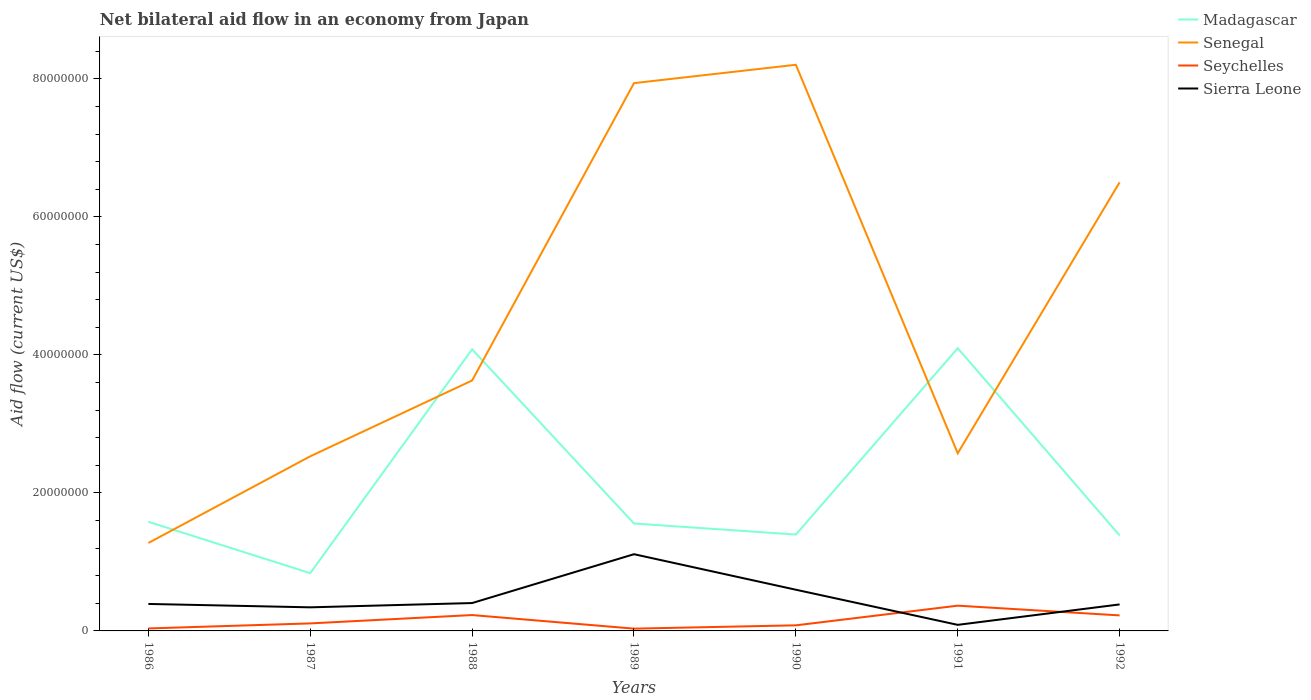How many different coloured lines are there?
Keep it short and to the point. 4. Is the number of lines equal to the number of legend labels?
Give a very brief answer. Yes. Across all years, what is the maximum net bilateral aid flow in Madagascar?
Your answer should be very brief. 8.37e+06. In which year was the net bilateral aid flow in Seychelles maximum?
Your response must be concise. 1989. What is the total net bilateral aid flow in Madagascar in the graph?
Your answer should be very brief. 2.52e+07. What is the difference between the highest and the second highest net bilateral aid flow in Sierra Leone?
Your answer should be compact. 1.02e+07. Is the net bilateral aid flow in Seychelles strictly greater than the net bilateral aid flow in Madagascar over the years?
Your answer should be very brief. Yes. What is the difference between two consecutive major ticks on the Y-axis?
Offer a terse response. 2.00e+07. Are the values on the major ticks of Y-axis written in scientific E-notation?
Ensure brevity in your answer.  No. Does the graph contain any zero values?
Make the answer very short. No. Does the graph contain grids?
Give a very brief answer. No. Where does the legend appear in the graph?
Provide a short and direct response. Top right. What is the title of the graph?
Offer a very short reply. Net bilateral aid flow in an economy from Japan. Does "Nicaragua" appear as one of the legend labels in the graph?
Offer a terse response. No. What is the label or title of the X-axis?
Make the answer very short. Years. What is the Aid flow (current US$) of Madagascar in 1986?
Provide a succinct answer. 1.58e+07. What is the Aid flow (current US$) in Senegal in 1986?
Your answer should be compact. 1.28e+07. What is the Aid flow (current US$) in Sierra Leone in 1986?
Keep it short and to the point. 3.91e+06. What is the Aid flow (current US$) of Madagascar in 1987?
Keep it short and to the point. 8.37e+06. What is the Aid flow (current US$) in Senegal in 1987?
Keep it short and to the point. 2.53e+07. What is the Aid flow (current US$) in Seychelles in 1987?
Give a very brief answer. 1.09e+06. What is the Aid flow (current US$) in Sierra Leone in 1987?
Offer a very short reply. 3.42e+06. What is the Aid flow (current US$) of Madagascar in 1988?
Ensure brevity in your answer.  4.08e+07. What is the Aid flow (current US$) in Senegal in 1988?
Your answer should be compact. 3.63e+07. What is the Aid flow (current US$) of Seychelles in 1988?
Provide a succinct answer. 2.30e+06. What is the Aid flow (current US$) of Sierra Leone in 1988?
Your response must be concise. 4.04e+06. What is the Aid flow (current US$) in Madagascar in 1989?
Keep it short and to the point. 1.56e+07. What is the Aid flow (current US$) in Senegal in 1989?
Provide a succinct answer. 7.94e+07. What is the Aid flow (current US$) of Sierra Leone in 1989?
Keep it short and to the point. 1.11e+07. What is the Aid flow (current US$) in Madagascar in 1990?
Offer a very short reply. 1.40e+07. What is the Aid flow (current US$) in Senegal in 1990?
Your answer should be very brief. 8.21e+07. What is the Aid flow (current US$) of Seychelles in 1990?
Your response must be concise. 8.10e+05. What is the Aid flow (current US$) of Sierra Leone in 1990?
Your answer should be very brief. 5.97e+06. What is the Aid flow (current US$) in Madagascar in 1991?
Keep it short and to the point. 4.10e+07. What is the Aid flow (current US$) in Senegal in 1991?
Make the answer very short. 2.58e+07. What is the Aid flow (current US$) of Seychelles in 1991?
Make the answer very short. 3.66e+06. What is the Aid flow (current US$) in Sierra Leone in 1991?
Your response must be concise. 8.80e+05. What is the Aid flow (current US$) in Madagascar in 1992?
Offer a very short reply. 1.38e+07. What is the Aid flow (current US$) in Senegal in 1992?
Provide a short and direct response. 6.50e+07. What is the Aid flow (current US$) in Seychelles in 1992?
Provide a succinct answer. 2.25e+06. What is the Aid flow (current US$) of Sierra Leone in 1992?
Your response must be concise. 3.84e+06. Across all years, what is the maximum Aid flow (current US$) in Madagascar?
Ensure brevity in your answer.  4.10e+07. Across all years, what is the maximum Aid flow (current US$) of Senegal?
Your response must be concise. 8.21e+07. Across all years, what is the maximum Aid flow (current US$) of Seychelles?
Offer a terse response. 3.66e+06. Across all years, what is the maximum Aid flow (current US$) of Sierra Leone?
Your answer should be compact. 1.11e+07. Across all years, what is the minimum Aid flow (current US$) in Madagascar?
Offer a very short reply. 8.37e+06. Across all years, what is the minimum Aid flow (current US$) of Senegal?
Make the answer very short. 1.28e+07. Across all years, what is the minimum Aid flow (current US$) of Seychelles?
Your answer should be compact. 3.30e+05. Across all years, what is the minimum Aid flow (current US$) of Sierra Leone?
Give a very brief answer. 8.80e+05. What is the total Aid flow (current US$) of Madagascar in the graph?
Offer a terse response. 1.49e+08. What is the total Aid flow (current US$) of Senegal in the graph?
Keep it short and to the point. 3.27e+08. What is the total Aid flow (current US$) in Seychelles in the graph?
Offer a very short reply. 1.08e+07. What is the total Aid flow (current US$) in Sierra Leone in the graph?
Give a very brief answer. 3.32e+07. What is the difference between the Aid flow (current US$) in Madagascar in 1986 and that in 1987?
Your answer should be very brief. 7.45e+06. What is the difference between the Aid flow (current US$) in Senegal in 1986 and that in 1987?
Your answer should be compact. -1.26e+07. What is the difference between the Aid flow (current US$) in Seychelles in 1986 and that in 1987?
Give a very brief answer. -7.30e+05. What is the difference between the Aid flow (current US$) of Madagascar in 1986 and that in 1988?
Make the answer very short. -2.50e+07. What is the difference between the Aid flow (current US$) of Senegal in 1986 and that in 1988?
Offer a very short reply. -2.36e+07. What is the difference between the Aid flow (current US$) in Seychelles in 1986 and that in 1988?
Offer a terse response. -1.94e+06. What is the difference between the Aid flow (current US$) of Sierra Leone in 1986 and that in 1988?
Give a very brief answer. -1.30e+05. What is the difference between the Aid flow (current US$) in Senegal in 1986 and that in 1989?
Offer a very short reply. -6.66e+07. What is the difference between the Aid flow (current US$) of Sierra Leone in 1986 and that in 1989?
Give a very brief answer. -7.21e+06. What is the difference between the Aid flow (current US$) of Madagascar in 1986 and that in 1990?
Keep it short and to the point. 1.85e+06. What is the difference between the Aid flow (current US$) of Senegal in 1986 and that in 1990?
Offer a terse response. -6.93e+07. What is the difference between the Aid flow (current US$) of Seychelles in 1986 and that in 1990?
Ensure brevity in your answer.  -4.50e+05. What is the difference between the Aid flow (current US$) in Sierra Leone in 1986 and that in 1990?
Make the answer very short. -2.06e+06. What is the difference between the Aid flow (current US$) of Madagascar in 1986 and that in 1991?
Give a very brief answer. -2.52e+07. What is the difference between the Aid flow (current US$) in Senegal in 1986 and that in 1991?
Your response must be concise. -1.30e+07. What is the difference between the Aid flow (current US$) of Seychelles in 1986 and that in 1991?
Provide a succinct answer. -3.30e+06. What is the difference between the Aid flow (current US$) of Sierra Leone in 1986 and that in 1991?
Your response must be concise. 3.03e+06. What is the difference between the Aid flow (current US$) in Madagascar in 1986 and that in 1992?
Provide a succinct answer. 1.98e+06. What is the difference between the Aid flow (current US$) of Senegal in 1986 and that in 1992?
Offer a very short reply. -5.23e+07. What is the difference between the Aid flow (current US$) of Seychelles in 1986 and that in 1992?
Your answer should be very brief. -1.89e+06. What is the difference between the Aid flow (current US$) in Sierra Leone in 1986 and that in 1992?
Offer a very short reply. 7.00e+04. What is the difference between the Aid flow (current US$) in Madagascar in 1987 and that in 1988?
Make the answer very short. -3.24e+07. What is the difference between the Aid flow (current US$) in Senegal in 1987 and that in 1988?
Your answer should be very brief. -1.10e+07. What is the difference between the Aid flow (current US$) of Seychelles in 1987 and that in 1988?
Provide a short and direct response. -1.21e+06. What is the difference between the Aid flow (current US$) in Sierra Leone in 1987 and that in 1988?
Give a very brief answer. -6.20e+05. What is the difference between the Aid flow (current US$) in Madagascar in 1987 and that in 1989?
Ensure brevity in your answer.  -7.20e+06. What is the difference between the Aid flow (current US$) of Senegal in 1987 and that in 1989?
Give a very brief answer. -5.41e+07. What is the difference between the Aid flow (current US$) in Seychelles in 1987 and that in 1989?
Your answer should be compact. 7.60e+05. What is the difference between the Aid flow (current US$) of Sierra Leone in 1987 and that in 1989?
Give a very brief answer. -7.70e+06. What is the difference between the Aid flow (current US$) in Madagascar in 1987 and that in 1990?
Your answer should be very brief. -5.60e+06. What is the difference between the Aid flow (current US$) in Senegal in 1987 and that in 1990?
Your answer should be very brief. -5.68e+07. What is the difference between the Aid flow (current US$) of Sierra Leone in 1987 and that in 1990?
Your answer should be compact. -2.55e+06. What is the difference between the Aid flow (current US$) in Madagascar in 1987 and that in 1991?
Offer a terse response. -3.26e+07. What is the difference between the Aid flow (current US$) in Senegal in 1987 and that in 1991?
Provide a short and direct response. -4.40e+05. What is the difference between the Aid flow (current US$) in Seychelles in 1987 and that in 1991?
Your response must be concise. -2.57e+06. What is the difference between the Aid flow (current US$) of Sierra Leone in 1987 and that in 1991?
Offer a terse response. 2.54e+06. What is the difference between the Aid flow (current US$) in Madagascar in 1987 and that in 1992?
Provide a succinct answer. -5.47e+06. What is the difference between the Aid flow (current US$) in Senegal in 1987 and that in 1992?
Keep it short and to the point. -3.97e+07. What is the difference between the Aid flow (current US$) in Seychelles in 1987 and that in 1992?
Ensure brevity in your answer.  -1.16e+06. What is the difference between the Aid flow (current US$) of Sierra Leone in 1987 and that in 1992?
Your answer should be compact. -4.20e+05. What is the difference between the Aid flow (current US$) in Madagascar in 1988 and that in 1989?
Provide a succinct answer. 2.52e+07. What is the difference between the Aid flow (current US$) in Senegal in 1988 and that in 1989?
Ensure brevity in your answer.  -4.31e+07. What is the difference between the Aid flow (current US$) of Seychelles in 1988 and that in 1989?
Provide a short and direct response. 1.97e+06. What is the difference between the Aid flow (current US$) of Sierra Leone in 1988 and that in 1989?
Provide a succinct answer. -7.08e+06. What is the difference between the Aid flow (current US$) in Madagascar in 1988 and that in 1990?
Your answer should be compact. 2.68e+07. What is the difference between the Aid flow (current US$) of Senegal in 1988 and that in 1990?
Offer a terse response. -4.58e+07. What is the difference between the Aid flow (current US$) in Seychelles in 1988 and that in 1990?
Your answer should be compact. 1.49e+06. What is the difference between the Aid flow (current US$) in Sierra Leone in 1988 and that in 1990?
Keep it short and to the point. -1.93e+06. What is the difference between the Aid flow (current US$) in Madagascar in 1988 and that in 1991?
Provide a succinct answer. -1.60e+05. What is the difference between the Aid flow (current US$) of Senegal in 1988 and that in 1991?
Your response must be concise. 1.06e+07. What is the difference between the Aid flow (current US$) in Seychelles in 1988 and that in 1991?
Make the answer very short. -1.36e+06. What is the difference between the Aid flow (current US$) of Sierra Leone in 1988 and that in 1991?
Provide a short and direct response. 3.16e+06. What is the difference between the Aid flow (current US$) of Madagascar in 1988 and that in 1992?
Ensure brevity in your answer.  2.70e+07. What is the difference between the Aid flow (current US$) of Senegal in 1988 and that in 1992?
Offer a terse response. -2.87e+07. What is the difference between the Aid flow (current US$) in Seychelles in 1988 and that in 1992?
Ensure brevity in your answer.  5.00e+04. What is the difference between the Aid flow (current US$) in Madagascar in 1989 and that in 1990?
Offer a terse response. 1.60e+06. What is the difference between the Aid flow (current US$) in Senegal in 1989 and that in 1990?
Give a very brief answer. -2.66e+06. What is the difference between the Aid flow (current US$) of Seychelles in 1989 and that in 1990?
Offer a very short reply. -4.80e+05. What is the difference between the Aid flow (current US$) in Sierra Leone in 1989 and that in 1990?
Provide a short and direct response. 5.15e+06. What is the difference between the Aid flow (current US$) of Madagascar in 1989 and that in 1991?
Provide a succinct answer. -2.54e+07. What is the difference between the Aid flow (current US$) in Senegal in 1989 and that in 1991?
Offer a terse response. 5.36e+07. What is the difference between the Aid flow (current US$) of Seychelles in 1989 and that in 1991?
Ensure brevity in your answer.  -3.33e+06. What is the difference between the Aid flow (current US$) of Sierra Leone in 1989 and that in 1991?
Offer a terse response. 1.02e+07. What is the difference between the Aid flow (current US$) in Madagascar in 1989 and that in 1992?
Give a very brief answer. 1.73e+06. What is the difference between the Aid flow (current US$) of Senegal in 1989 and that in 1992?
Make the answer very short. 1.44e+07. What is the difference between the Aid flow (current US$) of Seychelles in 1989 and that in 1992?
Make the answer very short. -1.92e+06. What is the difference between the Aid flow (current US$) of Sierra Leone in 1989 and that in 1992?
Provide a short and direct response. 7.28e+06. What is the difference between the Aid flow (current US$) in Madagascar in 1990 and that in 1991?
Give a very brief answer. -2.70e+07. What is the difference between the Aid flow (current US$) in Senegal in 1990 and that in 1991?
Provide a succinct answer. 5.63e+07. What is the difference between the Aid flow (current US$) in Seychelles in 1990 and that in 1991?
Your response must be concise. -2.85e+06. What is the difference between the Aid flow (current US$) in Sierra Leone in 1990 and that in 1991?
Keep it short and to the point. 5.09e+06. What is the difference between the Aid flow (current US$) of Madagascar in 1990 and that in 1992?
Your response must be concise. 1.30e+05. What is the difference between the Aid flow (current US$) of Senegal in 1990 and that in 1992?
Offer a very short reply. 1.70e+07. What is the difference between the Aid flow (current US$) of Seychelles in 1990 and that in 1992?
Your answer should be compact. -1.44e+06. What is the difference between the Aid flow (current US$) in Sierra Leone in 1990 and that in 1992?
Your answer should be very brief. 2.13e+06. What is the difference between the Aid flow (current US$) in Madagascar in 1991 and that in 1992?
Keep it short and to the point. 2.71e+07. What is the difference between the Aid flow (current US$) of Senegal in 1991 and that in 1992?
Offer a terse response. -3.93e+07. What is the difference between the Aid flow (current US$) of Seychelles in 1991 and that in 1992?
Offer a terse response. 1.41e+06. What is the difference between the Aid flow (current US$) in Sierra Leone in 1991 and that in 1992?
Ensure brevity in your answer.  -2.96e+06. What is the difference between the Aid flow (current US$) in Madagascar in 1986 and the Aid flow (current US$) in Senegal in 1987?
Offer a very short reply. -9.49e+06. What is the difference between the Aid flow (current US$) of Madagascar in 1986 and the Aid flow (current US$) of Seychelles in 1987?
Provide a succinct answer. 1.47e+07. What is the difference between the Aid flow (current US$) of Madagascar in 1986 and the Aid flow (current US$) of Sierra Leone in 1987?
Make the answer very short. 1.24e+07. What is the difference between the Aid flow (current US$) of Senegal in 1986 and the Aid flow (current US$) of Seychelles in 1987?
Your answer should be very brief. 1.17e+07. What is the difference between the Aid flow (current US$) of Senegal in 1986 and the Aid flow (current US$) of Sierra Leone in 1987?
Make the answer very short. 9.33e+06. What is the difference between the Aid flow (current US$) in Seychelles in 1986 and the Aid flow (current US$) in Sierra Leone in 1987?
Your answer should be very brief. -3.06e+06. What is the difference between the Aid flow (current US$) in Madagascar in 1986 and the Aid flow (current US$) in Senegal in 1988?
Give a very brief answer. -2.05e+07. What is the difference between the Aid flow (current US$) in Madagascar in 1986 and the Aid flow (current US$) in Seychelles in 1988?
Offer a terse response. 1.35e+07. What is the difference between the Aid flow (current US$) in Madagascar in 1986 and the Aid flow (current US$) in Sierra Leone in 1988?
Your response must be concise. 1.18e+07. What is the difference between the Aid flow (current US$) in Senegal in 1986 and the Aid flow (current US$) in Seychelles in 1988?
Your answer should be compact. 1.04e+07. What is the difference between the Aid flow (current US$) of Senegal in 1986 and the Aid flow (current US$) of Sierra Leone in 1988?
Offer a terse response. 8.71e+06. What is the difference between the Aid flow (current US$) of Seychelles in 1986 and the Aid flow (current US$) of Sierra Leone in 1988?
Keep it short and to the point. -3.68e+06. What is the difference between the Aid flow (current US$) in Madagascar in 1986 and the Aid flow (current US$) in Senegal in 1989?
Ensure brevity in your answer.  -6.36e+07. What is the difference between the Aid flow (current US$) in Madagascar in 1986 and the Aid flow (current US$) in Seychelles in 1989?
Provide a succinct answer. 1.55e+07. What is the difference between the Aid flow (current US$) of Madagascar in 1986 and the Aid flow (current US$) of Sierra Leone in 1989?
Your answer should be very brief. 4.70e+06. What is the difference between the Aid flow (current US$) of Senegal in 1986 and the Aid flow (current US$) of Seychelles in 1989?
Your answer should be compact. 1.24e+07. What is the difference between the Aid flow (current US$) in Senegal in 1986 and the Aid flow (current US$) in Sierra Leone in 1989?
Your answer should be compact. 1.63e+06. What is the difference between the Aid flow (current US$) of Seychelles in 1986 and the Aid flow (current US$) of Sierra Leone in 1989?
Provide a succinct answer. -1.08e+07. What is the difference between the Aid flow (current US$) in Madagascar in 1986 and the Aid flow (current US$) in Senegal in 1990?
Provide a succinct answer. -6.62e+07. What is the difference between the Aid flow (current US$) of Madagascar in 1986 and the Aid flow (current US$) of Seychelles in 1990?
Your answer should be very brief. 1.50e+07. What is the difference between the Aid flow (current US$) of Madagascar in 1986 and the Aid flow (current US$) of Sierra Leone in 1990?
Your answer should be very brief. 9.85e+06. What is the difference between the Aid flow (current US$) of Senegal in 1986 and the Aid flow (current US$) of Seychelles in 1990?
Provide a short and direct response. 1.19e+07. What is the difference between the Aid flow (current US$) in Senegal in 1986 and the Aid flow (current US$) in Sierra Leone in 1990?
Offer a very short reply. 6.78e+06. What is the difference between the Aid flow (current US$) of Seychelles in 1986 and the Aid flow (current US$) of Sierra Leone in 1990?
Offer a very short reply. -5.61e+06. What is the difference between the Aid flow (current US$) of Madagascar in 1986 and the Aid flow (current US$) of Senegal in 1991?
Ensure brevity in your answer.  -9.93e+06. What is the difference between the Aid flow (current US$) in Madagascar in 1986 and the Aid flow (current US$) in Seychelles in 1991?
Your answer should be compact. 1.22e+07. What is the difference between the Aid flow (current US$) of Madagascar in 1986 and the Aid flow (current US$) of Sierra Leone in 1991?
Your answer should be compact. 1.49e+07. What is the difference between the Aid flow (current US$) of Senegal in 1986 and the Aid flow (current US$) of Seychelles in 1991?
Your response must be concise. 9.09e+06. What is the difference between the Aid flow (current US$) in Senegal in 1986 and the Aid flow (current US$) in Sierra Leone in 1991?
Your answer should be compact. 1.19e+07. What is the difference between the Aid flow (current US$) of Seychelles in 1986 and the Aid flow (current US$) of Sierra Leone in 1991?
Provide a succinct answer. -5.20e+05. What is the difference between the Aid flow (current US$) in Madagascar in 1986 and the Aid flow (current US$) in Senegal in 1992?
Offer a very short reply. -4.92e+07. What is the difference between the Aid flow (current US$) of Madagascar in 1986 and the Aid flow (current US$) of Seychelles in 1992?
Your answer should be compact. 1.36e+07. What is the difference between the Aid flow (current US$) of Madagascar in 1986 and the Aid flow (current US$) of Sierra Leone in 1992?
Offer a very short reply. 1.20e+07. What is the difference between the Aid flow (current US$) of Senegal in 1986 and the Aid flow (current US$) of Seychelles in 1992?
Your answer should be very brief. 1.05e+07. What is the difference between the Aid flow (current US$) in Senegal in 1986 and the Aid flow (current US$) in Sierra Leone in 1992?
Offer a terse response. 8.91e+06. What is the difference between the Aid flow (current US$) of Seychelles in 1986 and the Aid flow (current US$) of Sierra Leone in 1992?
Make the answer very short. -3.48e+06. What is the difference between the Aid flow (current US$) in Madagascar in 1987 and the Aid flow (current US$) in Senegal in 1988?
Provide a succinct answer. -2.79e+07. What is the difference between the Aid flow (current US$) in Madagascar in 1987 and the Aid flow (current US$) in Seychelles in 1988?
Keep it short and to the point. 6.07e+06. What is the difference between the Aid flow (current US$) of Madagascar in 1987 and the Aid flow (current US$) of Sierra Leone in 1988?
Ensure brevity in your answer.  4.33e+06. What is the difference between the Aid flow (current US$) of Senegal in 1987 and the Aid flow (current US$) of Seychelles in 1988?
Keep it short and to the point. 2.30e+07. What is the difference between the Aid flow (current US$) of Senegal in 1987 and the Aid flow (current US$) of Sierra Leone in 1988?
Your response must be concise. 2.13e+07. What is the difference between the Aid flow (current US$) in Seychelles in 1987 and the Aid flow (current US$) in Sierra Leone in 1988?
Give a very brief answer. -2.95e+06. What is the difference between the Aid flow (current US$) of Madagascar in 1987 and the Aid flow (current US$) of Senegal in 1989?
Give a very brief answer. -7.10e+07. What is the difference between the Aid flow (current US$) in Madagascar in 1987 and the Aid flow (current US$) in Seychelles in 1989?
Your answer should be compact. 8.04e+06. What is the difference between the Aid flow (current US$) in Madagascar in 1987 and the Aid flow (current US$) in Sierra Leone in 1989?
Your answer should be compact. -2.75e+06. What is the difference between the Aid flow (current US$) in Senegal in 1987 and the Aid flow (current US$) in Seychelles in 1989?
Offer a terse response. 2.50e+07. What is the difference between the Aid flow (current US$) in Senegal in 1987 and the Aid flow (current US$) in Sierra Leone in 1989?
Your response must be concise. 1.42e+07. What is the difference between the Aid flow (current US$) in Seychelles in 1987 and the Aid flow (current US$) in Sierra Leone in 1989?
Provide a succinct answer. -1.00e+07. What is the difference between the Aid flow (current US$) in Madagascar in 1987 and the Aid flow (current US$) in Senegal in 1990?
Give a very brief answer. -7.37e+07. What is the difference between the Aid flow (current US$) of Madagascar in 1987 and the Aid flow (current US$) of Seychelles in 1990?
Keep it short and to the point. 7.56e+06. What is the difference between the Aid flow (current US$) of Madagascar in 1987 and the Aid flow (current US$) of Sierra Leone in 1990?
Your response must be concise. 2.40e+06. What is the difference between the Aid flow (current US$) of Senegal in 1987 and the Aid flow (current US$) of Seychelles in 1990?
Your answer should be very brief. 2.45e+07. What is the difference between the Aid flow (current US$) in Senegal in 1987 and the Aid flow (current US$) in Sierra Leone in 1990?
Ensure brevity in your answer.  1.93e+07. What is the difference between the Aid flow (current US$) in Seychelles in 1987 and the Aid flow (current US$) in Sierra Leone in 1990?
Provide a succinct answer. -4.88e+06. What is the difference between the Aid flow (current US$) of Madagascar in 1987 and the Aid flow (current US$) of Senegal in 1991?
Your answer should be compact. -1.74e+07. What is the difference between the Aid flow (current US$) in Madagascar in 1987 and the Aid flow (current US$) in Seychelles in 1991?
Offer a very short reply. 4.71e+06. What is the difference between the Aid flow (current US$) in Madagascar in 1987 and the Aid flow (current US$) in Sierra Leone in 1991?
Offer a very short reply. 7.49e+06. What is the difference between the Aid flow (current US$) in Senegal in 1987 and the Aid flow (current US$) in Seychelles in 1991?
Keep it short and to the point. 2.16e+07. What is the difference between the Aid flow (current US$) in Senegal in 1987 and the Aid flow (current US$) in Sierra Leone in 1991?
Give a very brief answer. 2.44e+07. What is the difference between the Aid flow (current US$) in Madagascar in 1987 and the Aid flow (current US$) in Senegal in 1992?
Provide a succinct answer. -5.66e+07. What is the difference between the Aid flow (current US$) in Madagascar in 1987 and the Aid flow (current US$) in Seychelles in 1992?
Provide a succinct answer. 6.12e+06. What is the difference between the Aid flow (current US$) in Madagascar in 1987 and the Aid flow (current US$) in Sierra Leone in 1992?
Give a very brief answer. 4.53e+06. What is the difference between the Aid flow (current US$) in Senegal in 1987 and the Aid flow (current US$) in Seychelles in 1992?
Offer a terse response. 2.31e+07. What is the difference between the Aid flow (current US$) in Senegal in 1987 and the Aid flow (current US$) in Sierra Leone in 1992?
Your answer should be compact. 2.15e+07. What is the difference between the Aid flow (current US$) in Seychelles in 1987 and the Aid flow (current US$) in Sierra Leone in 1992?
Keep it short and to the point. -2.75e+06. What is the difference between the Aid flow (current US$) of Madagascar in 1988 and the Aid flow (current US$) of Senegal in 1989?
Provide a succinct answer. -3.86e+07. What is the difference between the Aid flow (current US$) in Madagascar in 1988 and the Aid flow (current US$) in Seychelles in 1989?
Your answer should be compact. 4.05e+07. What is the difference between the Aid flow (current US$) in Madagascar in 1988 and the Aid flow (current US$) in Sierra Leone in 1989?
Provide a short and direct response. 2.97e+07. What is the difference between the Aid flow (current US$) of Senegal in 1988 and the Aid flow (current US$) of Seychelles in 1989?
Give a very brief answer. 3.60e+07. What is the difference between the Aid flow (current US$) in Senegal in 1988 and the Aid flow (current US$) in Sierra Leone in 1989?
Your answer should be very brief. 2.52e+07. What is the difference between the Aid flow (current US$) in Seychelles in 1988 and the Aid flow (current US$) in Sierra Leone in 1989?
Provide a short and direct response. -8.82e+06. What is the difference between the Aid flow (current US$) in Madagascar in 1988 and the Aid flow (current US$) in Senegal in 1990?
Provide a succinct answer. -4.12e+07. What is the difference between the Aid flow (current US$) of Madagascar in 1988 and the Aid flow (current US$) of Seychelles in 1990?
Make the answer very short. 4.00e+07. What is the difference between the Aid flow (current US$) in Madagascar in 1988 and the Aid flow (current US$) in Sierra Leone in 1990?
Make the answer very short. 3.48e+07. What is the difference between the Aid flow (current US$) in Senegal in 1988 and the Aid flow (current US$) in Seychelles in 1990?
Provide a succinct answer. 3.55e+07. What is the difference between the Aid flow (current US$) of Senegal in 1988 and the Aid flow (current US$) of Sierra Leone in 1990?
Keep it short and to the point. 3.03e+07. What is the difference between the Aid flow (current US$) of Seychelles in 1988 and the Aid flow (current US$) of Sierra Leone in 1990?
Offer a very short reply. -3.67e+06. What is the difference between the Aid flow (current US$) of Madagascar in 1988 and the Aid flow (current US$) of Senegal in 1991?
Make the answer very short. 1.51e+07. What is the difference between the Aid flow (current US$) of Madagascar in 1988 and the Aid flow (current US$) of Seychelles in 1991?
Your answer should be very brief. 3.72e+07. What is the difference between the Aid flow (current US$) of Madagascar in 1988 and the Aid flow (current US$) of Sierra Leone in 1991?
Make the answer very short. 3.99e+07. What is the difference between the Aid flow (current US$) in Senegal in 1988 and the Aid flow (current US$) in Seychelles in 1991?
Offer a terse response. 3.26e+07. What is the difference between the Aid flow (current US$) in Senegal in 1988 and the Aid flow (current US$) in Sierra Leone in 1991?
Provide a succinct answer. 3.54e+07. What is the difference between the Aid flow (current US$) in Seychelles in 1988 and the Aid flow (current US$) in Sierra Leone in 1991?
Ensure brevity in your answer.  1.42e+06. What is the difference between the Aid flow (current US$) of Madagascar in 1988 and the Aid flow (current US$) of Senegal in 1992?
Give a very brief answer. -2.42e+07. What is the difference between the Aid flow (current US$) of Madagascar in 1988 and the Aid flow (current US$) of Seychelles in 1992?
Offer a very short reply. 3.86e+07. What is the difference between the Aid flow (current US$) of Madagascar in 1988 and the Aid flow (current US$) of Sierra Leone in 1992?
Ensure brevity in your answer.  3.70e+07. What is the difference between the Aid flow (current US$) of Senegal in 1988 and the Aid flow (current US$) of Seychelles in 1992?
Provide a short and direct response. 3.40e+07. What is the difference between the Aid flow (current US$) of Senegal in 1988 and the Aid flow (current US$) of Sierra Leone in 1992?
Your answer should be compact. 3.25e+07. What is the difference between the Aid flow (current US$) in Seychelles in 1988 and the Aid flow (current US$) in Sierra Leone in 1992?
Provide a succinct answer. -1.54e+06. What is the difference between the Aid flow (current US$) in Madagascar in 1989 and the Aid flow (current US$) in Senegal in 1990?
Your answer should be very brief. -6.65e+07. What is the difference between the Aid flow (current US$) in Madagascar in 1989 and the Aid flow (current US$) in Seychelles in 1990?
Provide a succinct answer. 1.48e+07. What is the difference between the Aid flow (current US$) of Madagascar in 1989 and the Aid flow (current US$) of Sierra Leone in 1990?
Give a very brief answer. 9.60e+06. What is the difference between the Aid flow (current US$) of Senegal in 1989 and the Aid flow (current US$) of Seychelles in 1990?
Make the answer very short. 7.86e+07. What is the difference between the Aid flow (current US$) of Senegal in 1989 and the Aid flow (current US$) of Sierra Leone in 1990?
Offer a terse response. 7.34e+07. What is the difference between the Aid flow (current US$) in Seychelles in 1989 and the Aid flow (current US$) in Sierra Leone in 1990?
Ensure brevity in your answer.  -5.64e+06. What is the difference between the Aid flow (current US$) of Madagascar in 1989 and the Aid flow (current US$) of Senegal in 1991?
Give a very brief answer. -1.02e+07. What is the difference between the Aid flow (current US$) in Madagascar in 1989 and the Aid flow (current US$) in Seychelles in 1991?
Offer a very short reply. 1.19e+07. What is the difference between the Aid flow (current US$) in Madagascar in 1989 and the Aid flow (current US$) in Sierra Leone in 1991?
Ensure brevity in your answer.  1.47e+07. What is the difference between the Aid flow (current US$) in Senegal in 1989 and the Aid flow (current US$) in Seychelles in 1991?
Your answer should be very brief. 7.57e+07. What is the difference between the Aid flow (current US$) of Senegal in 1989 and the Aid flow (current US$) of Sierra Leone in 1991?
Make the answer very short. 7.85e+07. What is the difference between the Aid flow (current US$) in Seychelles in 1989 and the Aid flow (current US$) in Sierra Leone in 1991?
Your answer should be very brief. -5.50e+05. What is the difference between the Aid flow (current US$) in Madagascar in 1989 and the Aid flow (current US$) in Senegal in 1992?
Your answer should be compact. -4.94e+07. What is the difference between the Aid flow (current US$) of Madagascar in 1989 and the Aid flow (current US$) of Seychelles in 1992?
Make the answer very short. 1.33e+07. What is the difference between the Aid flow (current US$) in Madagascar in 1989 and the Aid flow (current US$) in Sierra Leone in 1992?
Keep it short and to the point. 1.17e+07. What is the difference between the Aid flow (current US$) of Senegal in 1989 and the Aid flow (current US$) of Seychelles in 1992?
Your answer should be compact. 7.72e+07. What is the difference between the Aid flow (current US$) of Senegal in 1989 and the Aid flow (current US$) of Sierra Leone in 1992?
Your response must be concise. 7.56e+07. What is the difference between the Aid flow (current US$) of Seychelles in 1989 and the Aid flow (current US$) of Sierra Leone in 1992?
Ensure brevity in your answer.  -3.51e+06. What is the difference between the Aid flow (current US$) in Madagascar in 1990 and the Aid flow (current US$) in Senegal in 1991?
Give a very brief answer. -1.18e+07. What is the difference between the Aid flow (current US$) of Madagascar in 1990 and the Aid flow (current US$) of Seychelles in 1991?
Your answer should be very brief. 1.03e+07. What is the difference between the Aid flow (current US$) of Madagascar in 1990 and the Aid flow (current US$) of Sierra Leone in 1991?
Your response must be concise. 1.31e+07. What is the difference between the Aid flow (current US$) in Senegal in 1990 and the Aid flow (current US$) in Seychelles in 1991?
Ensure brevity in your answer.  7.84e+07. What is the difference between the Aid flow (current US$) of Senegal in 1990 and the Aid flow (current US$) of Sierra Leone in 1991?
Keep it short and to the point. 8.12e+07. What is the difference between the Aid flow (current US$) in Madagascar in 1990 and the Aid flow (current US$) in Senegal in 1992?
Keep it short and to the point. -5.10e+07. What is the difference between the Aid flow (current US$) of Madagascar in 1990 and the Aid flow (current US$) of Seychelles in 1992?
Provide a short and direct response. 1.17e+07. What is the difference between the Aid flow (current US$) of Madagascar in 1990 and the Aid flow (current US$) of Sierra Leone in 1992?
Ensure brevity in your answer.  1.01e+07. What is the difference between the Aid flow (current US$) in Senegal in 1990 and the Aid flow (current US$) in Seychelles in 1992?
Offer a terse response. 7.98e+07. What is the difference between the Aid flow (current US$) in Senegal in 1990 and the Aid flow (current US$) in Sierra Leone in 1992?
Provide a succinct answer. 7.82e+07. What is the difference between the Aid flow (current US$) of Seychelles in 1990 and the Aid flow (current US$) of Sierra Leone in 1992?
Your response must be concise. -3.03e+06. What is the difference between the Aid flow (current US$) in Madagascar in 1991 and the Aid flow (current US$) in Senegal in 1992?
Ensure brevity in your answer.  -2.40e+07. What is the difference between the Aid flow (current US$) in Madagascar in 1991 and the Aid flow (current US$) in Seychelles in 1992?
Offer a very short reply. 3.87e+07. What is the difference between the Aid flow (current US$) of Madagascar in 1991 and the Aid flow (current US$) of Sierra Leone in 1992?
Offer a terse response. 3.71e+07. What is the difference between the Aid flow (current US$) of Senegal in 1991 and the Aid flow (current US$) of Seychelles in 1992?
Your answer should be very brief. 2.35e+07. What is the difference between the Aid flow (current US$) of Senegal in 1991 and the Aid flow (current US$) of Sierra Leone in 1992?
Provide a succinct answer. 2.19e+07. What is the average Aid flow (current US$) of Madagascar per year?
Provide a succinct answer. 2.13e+07. What is the average Aid flow (current US$) in Senegal per year?
Your answer should be very brief. 4.67e+07. What is the average Aid flow (current US$) in Seychelles per year?
Your answer should be compact. 1.54e+06. What is the average Aid flow (current US$) of Sierra Leone per year?
Ensure brevity in your answer.  4.74e+06. In the year 1986, what is the difference between the Aid flow (current US$) in Madagascar and Aid flow (current US$) in Senegal?
Your response must be concise. 3.07e+06. In the year 1986, what is the difference between the Aid flow (current US$) of Madagascar and Aid flow (current US$) of Seychelles?
Your response must be concise. 1.55e+07. In the year 1986, what is the difference between the Aid flow (current US$) in Madagascar and Aid flow (current US$) in Sierra Leone?
Your response must be concise. 1.19e+07. In the year 1986, what is the difference between the Aid flow (current US$) of Senegal and Aid flow (current US$) of Seychelles?
Offer a terse response. 1.24e+07. In the year 1986, what is the difference between the Aid flow (current US$) of Senegal and Aid flow (current US$) of Sierra Leone?
Offer a terse response. 8.84e+06. In the year 1986, what is the difference between the Aid flow (current US$) in Seychelles and Aid flow (current US$) in Sierra Leone?
Provide a short and direct response. -3.55e+06. In the year 1987, what is the difference between the Aid flow (current US$) of Madagascar and Aid flow (current US$) of Senegal?
Offer a very short reply. -1.69e+07. In the year 1987, what is the difference between the Aid flow (current US$) in Madagascar and Aid flow (current US$) in Seychelles?
Your answer should be compact. 7.28e+06. In the year 1987, what is the difference between the Aid flow (current US$) of Madagascar and Aid flow (current US$) of Sierra Leone?
Your answer should be compact. 4.95e+06. In the year 1987, what is the difference between the Aid flow (current US$) in Senegal and Aid flow (current US$) in Seychelles?
Ensure brevity in your answer.  2.42e+07. In the year 1987, what is the difference between the Aid flow (current US$) in Senegal and Aid flow (current US$) in Sierra Leone?
Offer a terse response. 2.19e+07. In the year 1987, what is the difference between the Aid flow (current US$) of Seychelles and Aid flow (current US$) of Sierra Leone?
Ensure brevity in your answer.  -2.33e+06. In the year 1988, what is the difference between the Aid flow (current US$) of Madagascar and Aid flow (current US$) of Senegal?
Your response must be concise. 4.52e+06. In the year 1988, what is the difference between the Aid flow (current US$) in Madagascar and Aid flow (current US$) in Seychelles?
Your answer should be compact. 3.85e+07. In the year 1988, what is the difference between the Aid flow (current US$) of Madagascar and Aid flow (current US$) of Sierra Leone?
Your answer should be very brief. 3.68e+07. In the year 1988, what is the difference between the Aid flow (current US$) in Senegal and Aid flow (current US$) in Seychelles?
Ensure brevity in your answer.  3.40e+07. In the year 1988, what is the difference between the Aid flow (current US$) in Senegal and Aid flow (current US$) in Sierra Leone?
Provide a short and direct response. 3.23e+07. In the year 1988, what is the difference between the Aid flow (current US$) in Seychelles and Aid flow (current US$) in Sierra Leone?
Offer a very short reply. -1.74e+06. In the year 1989, what is the difference between the Aid flow (current US$) of Madagascar and Aid flow (current US$) of Senegal?
Ensure brevity in your answer.  -6.38e+07. In the year 1989, what is the difference between the Aid flow (current US$) of Madagascar and Aid flow (current US$) of Seychelles?
Provide a succinct answer. 1.52e+07. In the year 1989, what is the difference between the Aid flow (current US$) in Madagascar and Aid flow (current US$) in Sierra Leone?
Your answer should be compact. 4.45e+06. In the year 1989, what is the difference between the Aid flow (current US$) in Senegal and Aid flow (current US$) in Seychelles?
Your response must be concise. 7.91e+07. In the year 1989, what is the difference between the Aid flow (current US$) of Senegal and Aid flow (current US$) of Sierra Leone?
Your answer should be compact. 6.83e+07. In the year 1989, what is the difference between the Aid flow (current US$) in Seychelles and Aid flow (current US$) in Sierra Leone?
Offer a very short reply. -1.08e+07. In the year 1990, what is the difference between the Aid flow (current US$) of Madagascar and Aid flow (current US$) of Senegal?
Ensure brevity in your answer.  -6.81e+07. In the year 1990, what is the difference between the Aid flow (current US$) in Madagascar and Aid flow (current US$) in Seychelles?
Keep it short and to the point. 1.32e+07. In the year 1990, what is the difference between the Aid flow (current US$) in Madagascar and Aid flow (current US$) in Sierra Leone?
Give a very brief answer. 8.00e+06. In the year 1990, what is the difference between the Aid flow (current US$) in Senegal and Aid flow (current US$) in Seychelles?
Offer a very short reply. 8.12e+07. In the year 1990, what is the difference between the Aid flow (current US$) of Senegal and Aid flow (current US$) of Sierra Leone?
Make the answer very short. 7.61e+07. In the year 1990, what is the difference between the Aid flow (current US$) of Seychelles and Aid flow (current US$) of Sierra Leone?
Make the answer very short. -5.16e+06. In the year 1991, what is the difference between the Aid flow (current US$) of Madagascar and Aid flow (current US$) of Senegal?
Provide a succinct answer. 1.52e+07. In the year 1991, what is the difference between the Aid flow (current US$) in Madagascar and Aid flow (current US$) in Seychelles?
Ensure brevity in your answer.  3.73e+07. In the year 1991, what is the difference between the Aid flow (current US$) in Madagascar and Aid flow (current US$) in Sierra Leone?
Offer a terse response. 4.01e+07. In the year 1991, what is the difference between the Aid flow (current US$) of Senegal and Aid flow (current US$) of Seychelles?
Your response must be concise. 2.21e+07. In the year 1991, what is the difference between the Aid flow (current US$) in Senegal and Aid flow (current US$) in Sierra Leone?
Make the answer very short. 2.49e+07. In the year 1991, what is the difference between the Aid flow (current US$) of Seychelles and Aid flow (current US$) of Sierra Leone?
Give a very brief answer. 2.78e+06. In the year 1992, what is the difference between the Aid flow (current US$) in Madagascar and Aid flow (current US$) in Senegal?
Keep it short and to the point. -5.12e+07. In the year 1992, what is the difference between the Aid flow (current US$) of Madagascar and Aid flow (current US$) of Seychelles?
Ensure brevity in your answer.  1.16e+07. In the year 1992, what is the difference between the Aid flow (current US$) in Madagascar and Aid flow (current US$) in Sierra Leone?
Keep it short and to the point. 1.00e+07. In the year 1992, what is the difference between the Aid flow (current US$) in Senegal and Aid flow (current US$) in Seychelles?
Offer a very short reply. 6.28e+07. In the year 1992, what is the difference between the Aid flow (current US$) of Senegal and Aid flow (current US$) of Sierra Leone?
Your answer should be compact. 6.12e+07. In the year 1992, what is the difference between the Aid flow (current US$) of Seychelles and Aid flow (current US$) of Sierra Leone?
Ensure brevity in your answer.  -1.59e+06. What is the ratio of the Aid flow (current US$) of Madagascar in 1986 to that in 1987?
Your answer should be compact. 1.89. What is the ratio of the Aid flow (current US$) in Senegal in 1986 to that in 1987?
Keep it short and to the point. 0.5. What is the ratio of the Aid flow (current US$) of Seychelles in 1986 to that in 1987?
Provide a short and direct response. 0.33. What is the ratio of the Aid flow (current US$) of Sierra Leone in 1986 to that in 1987?
Give a very brief answer. 1.14. What is the ratio of the Aid flow (current US$) in Madagascar in 1986 to that in 1988?
Offer a very short reply. 0.39. What is the ratio of the Aid flow (current US$) in Senegal in 1986 to that in 1988?
Keep it short and to the point. 0.35. What is the ratio of the Aid flow (current US$) in Seychelles in 1986 to that in 1988?
Make the answer very short. 0.16. What is the ratio of the Aid flow (current US$) in Sierra Leone in 1986 to that in 1988?
Offer a very short reply. 0.97. What is the ratio of the Aid flow (current US$) of Madagascar in 1986 to that in 1989?
Keep it short and to the point. 1.02. What is the ratio of the Aid flow (current US$) in Senegal in 1986 to that in 1989?
Keep it short and to the point. 0.16. What is the ratio of the Aid flow (current US$) of Sierra Leone in 1986 to that in 1989?
Offer a terse response. 0.35. What is the ratio of the Aid flow (current US$) in Madagascar in 1986 to that in 1990?
Give a very brief answer. 1.13. What is the ratio of the Aid flow (current US$) in Senegal in 1986 to that in 1990?
Provide a short and direct response. 0.16. What is the ratio of the Aid flow (current US$) of Seychelles in 1986 to that in 1990?
Provide a short and direct response. 0.44. What is the ratio of the Aid flow (current US$) of Sierra Leone in 1986 to that in 1990?
Your answer should be compact. 0.65. What is the ratio of the Aid flow (current US$) of Madagascar in 1986 to that in 1991?
Your answer should be compact. 0.39. What is the ratio of the Aid flow (current US$) in Senegal in 1986 to that in 1991?
Provide a succinct answer. 0.5. What is the ratio of the Aid flow (current US$) of Seychelles in 1986 to that in 1991?
Provide a short and direct response. 0.1. What is the ratio of the Aid flow (current US$) in Sierra Leone in 1986 to that in 1991?
Keep it short and to the point. 4.44. What is the ratio of the Aid flow (current US$) of Madagascar in 1986 to that in 1992?
Your answer should be compact. 1.14. What is the ratio of the Aid flow (current US$) in Senegal in 1986 to that in 1992?
Keep it short and to the point. 0.2. What is the ratio of the Aid flow (current US$) in Seychelles in 1986 to that in 1992?
Your answer should be compact. 0.16. What is the ratio of the Aid flow (current US$) in Sierra Leone in 1986 to that in 1992?
Keep it short and to the point. 1.02. What is the ratio of the Aid flow (current US$) of Madagascar in 1987 to that in 1988?
Keep it short and to the point. 0.2. What is the ratio of the Aid flow (current US$) of Senegal in 1987 to that in 1988?
Your answer should be compact. 0.7. What is the ratio of the Aid flow (current US$) of Seychelles in 1987 to that in 1988?
Ensure brevity in your answer.  0.47. What is the ratio of the Aid flow (current US$) in Sierra Leone in 1987 to that in 1988?
Ensure brevity in your answer.  0.85. What is the ratio of the Aid flow (current US$) of Madagascar in 1987 to that in 1989?
Your answer should be very brief. 0.54. What is the ratio of the Aid flow (current US$) in Senegal in 1987 to that in 1989?
Offer a terse response. 0.32. What is the ratio of the Aid flow (current US$) of Seychelles in 1987 to that in 1989?
Give a very brief answer. 3.3. What is the ratio of the Aid flow (current US$) in Sierra Leone in 1987 to that in 1989?
Your response must be concise. 0.31. What is the ratio of the Aid flow (current US$) in Madagascar in 1987 to that in 1990?
Ensure brevity in your answer.  0.6. What is the ratio of the Aid flow (current US$) in Senegal in 1987 to that in 1990?
Your response must be concise. 0.31. What is the ratio of the Aid flow (current US$) of Seychelles in 1987 to that in 1990?
Offer a very short reply. 1.35. What is the ratio of the Aid flow (current US$) of Sierra Leone in 1987 to that in 1990?
Make the answer very short. 0.57. What is the ratio of the Aid flow (current US$) of Madagascar in 1987 to that in 1991?
Your answer should be compact. 0.2. What is the ratio of the Aid flow (current US$) of Senegal in 1987 to that in 1991?
Your answer should be very brief. 0.98. What is the ratio of the Aid flow (current US$) in Seychelles in 1987 to that in 1991?
Offer a very short reply. 0.3. What is the ratio of the Aid flow (current US$) of Sierra Leone in 1987 to that in 1991?
Your answer should be very brief. 3.89. What is the ratio of the Aid flow (current US$) in Madagascar in 1987 to that in 1992?
Your answer should be very brief. 0.6. What is the ratio of the Aid flow (current US$) of Senegal in 1987 to that in 1992?
Offer a very short reply. 0.39. What is the ratio of the Aid flow (current US$) in Seychelles in 1987 to that in 1992?
Your answer should be very brief. 0.48. What is the ratio of the Aid flow (current US$) of Sierra Leone in 1987 to that in 1992?
Give a very brief answer. 0.89. What is the ratio of the Aid flow (current US$) in Madagascar in 1988 to that in 1989?
Offer a terse response. 2.62. What is the ratio of the Aid flow (current US$) of Senegal in 1988 to that in 1989?
Provide a succinct answer. 0.46. What is the ratio of the Aid flow (current US$) of Seychelles in 1988 to that in 1989?
Provide a succinct answer. 6.97. What is the ratio of the Aid flow (current US$) in Sierra Leone in 1988 to that in 1989?
Offer a very short reply. 0.36. What is the ratio of the Aid flow (current US$) of Madagascar in 1988 to that in 1990?
Keep it short and to the point. 2.92. What is the ratio of the Aid flow (current US$) in Senegal in 1988 to that in 1990?
Offer a terse response. 0.44. What is the ratio of the Aid flow (current US$) of Seychelles in 1988 to that in 1990?
Your response must be concise. 2.84. What is the ratio of the Aid flow (current US$) of Sierra Leone in 1988 to that in 1990?
Provide a short and direct response. 0.68. What is the ratio of the Aid flow (current US$) in Madagascar in 1988 to that in 1991?
Your answer should be very brief. 1. What is the ratio of the Aid flow (current US$) in Senegal in 1988 to that in 1991?
Provide a succinct answer. 1.41. What is the ratio of the Aid flow (current US$) of Seychelles in 1988 to that in 1991?
Offer a terse response. 0.63. What is the ratio of the Aid flow (current US$) in Sierra Leone in 1988 to that in 1991?
Your answer should be compact. 4.59. What is the ratio of the Aid flow (current US$) in Madagascar in 1988 to that in 1992?
Offer a terse response. 2.95. What is the ratio of the Aid flow (current US$) in Senegal in 1988 to that in 1992?
Make the answer very short. 0.56. What is the ratio of the Aid flow (current US$) in Seychelles in 1988 to that in 1992?
Provide a short and direct response. 1.02. What is the ratio of the Aid flow (current US$) in Sierra Leone in 1988 to that in 1992?
Keep it short and to the point. 1.05. What is the ratio of the Aid flow (current US$) in Madagascar in 1989 to that in 1990?
Make the answer very short. 1.11. What is the ratio of the Aid flow (current US$) of Senegal in 1989 to that in 1990?
Offer a terse response. 0.97. What is the ratio of the Aid flow (current US$) in Seychelles in 1989 to that in 1990?
Your answer should be very brief. 0.41. What is the ratio of the Aid flow (current US$) of Sierra Leone in 1989 to that in 1990?
Your response must be concise. 1.86. What is the ratio of the Aid flow (current US$) in Madagascar in 1989 to that in 1991?
Ensure brevity in your answer.  0.38. What is the ratio of the Aid flow (current US$) of Senegal in 1989 to that in 1991?
Make the answer very short. 3.08. What is the ratio of the Aid flow (current US$) in Seychelles in 1989 to that in 1991?
Keep it short and to the point. 0.09. What is the ratio of the Aid flow (current US$) in Sierra Leone in 1989 to that in 1991?
Offer a terse response. 12.64. What is the ratio of the Aid flow (current US$) of Madagascar in 1989 to that in 1992?
Provide a short and direct response. 1.12. What is the ratio of the Aid flow (current US$) in Senegal in 1989 to that in 1992?
Your answer should be very brief. 1.22. What is the ratio of the Aid flow (current US$) of Seychelles in 1989 to that in 1992?
Give a very brief answer. 0.15. What is the ratio of the Aid flow (current US$) in Sierra Leone in 1989 to that in 1992?
Provide a short and direct response. 2.9. What is the ratio of the Aid flow (current US$) in Madagascar in 1990 to that in 1991?
Keep it short and to the point. 0.34. What is the ratio of the Aid flow (current US$) of Senegal in 1990 to that in 1991?
Your answer should be compact. 3.19. What is the ratio of the Aid flow (current US$) of Seychelles in 1990 to that in 1991?
Keep it short and to the point. 0.22. What is the ratio of the Aid flow (current US$) in Sierra Leone in 1990 to that in 1991?
Keep it short and to the point. 6.78. What is the ratio of the Aid flow (current US$) of Madagascar in 1990 to that in 1992?
Provide a succinct answer. 1.01. What is the ratio of the Aid flow (current US$) of Senegal in 1990 to that in 1992?
Provide a succinct answer. 1.26. What is the ratio of the Aid flow (current US$) of Seychelles in 1990 to that in 1992?
Ensure brevity in your answer.  0.36. What is the ratio of the Aid flow (current US$) in Sierra Leone in 1990 to that in 1992?
Offer a terse response. 1.55. What is the ratio of the Aid flow (current US$) of Madagascar in 1991 to that in 1992?
Make the answer very short. 2.96. What is the ratio of the Aid flow (current US$) in Senegal in 1991 to that in 1992?
Make the answer very short. 0.4. What is the ratio of the Aid flow (current US$) in Seychelles in 1991 to that in 1992?
Your answer should be very brief. 1.63. What is the ratio of the Aid flow (current US$) of Sierra Leone in 1991 to that in 1992?
Offer a very short reply. 0.23. What is the difference between the highest and the second highest Aid flow (current US$) in Madagascar?
Your answer should be very brief. 1.60e+05. What is the difference between the highest and the second highest Aid flow (current US$) of Senegal?
Offer a very short reply. 2.66e+06. What is the difference between the highest and the second highest Aid flow (current US$) of Seychelles?
Your response must be concise. 1.36e+06. What is the difference between the highest and the second highest Aid flow (current US$) of Sierra Leone?
Provide a succinct answer. 5.15e+06. What is the difference between the highest and the lowest Aid flow (current US$) in Madagascar?
Keep it short and to the point. 3.26e+07. What is the difference between the highest and the lowest Aid flow (current US$) in Senegal?
Keep it short and to the point. 6.93e+07. What is the difference between the highest and the lowest Aid flow (current US$) of Seychelles?
Give a very brief answer. 3.33e+06. What is the difference between the highest and the lowest Aid flow (current US$) of Sierra Leone?
Ensure brevity in your answer.  1.02e+07. 